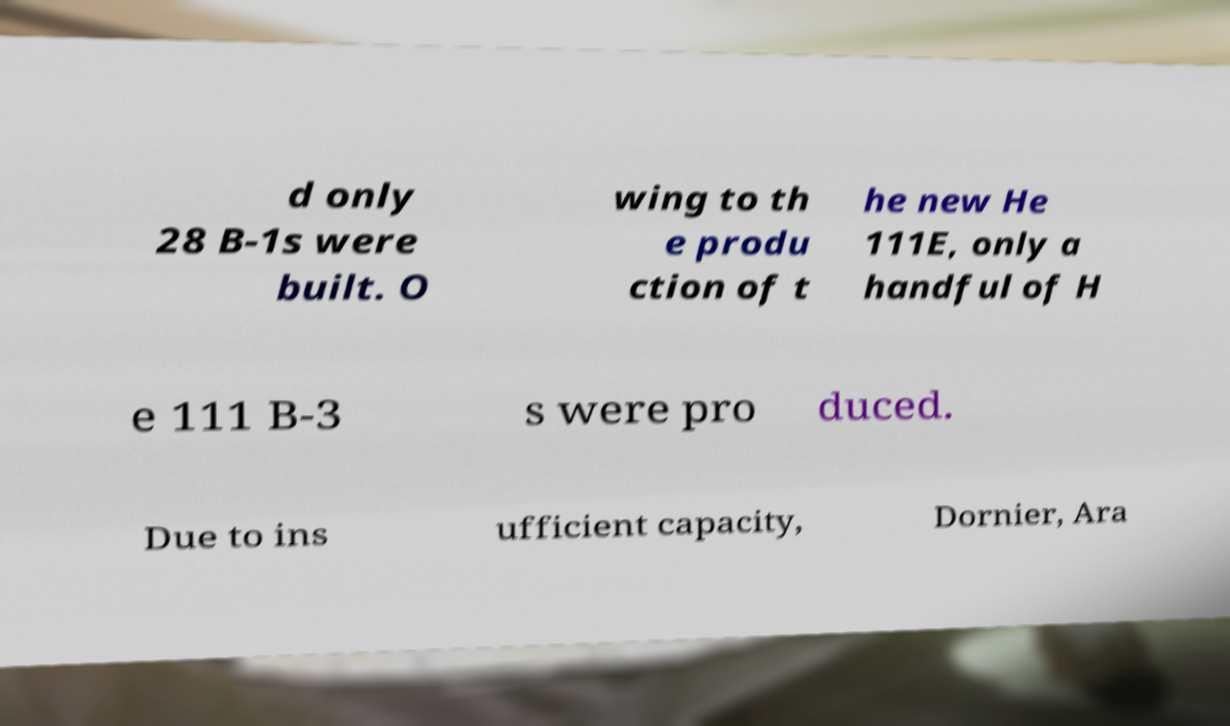Can you accurately transcribe the text from the provided image for me? d only 28 B-1s were built. O wing to th e produ ction of t he new He 111E, only a handful of H e 111 B-3 s were pro duced. Due to ins ufficient capacity, Dornier, Ara 